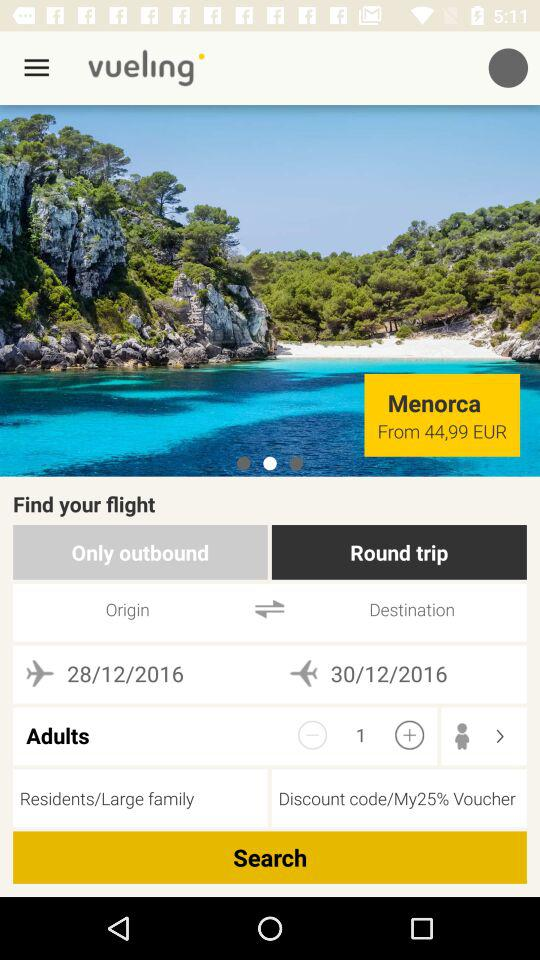What is the selected type of trip? The selected type of trip is "Round trip". 